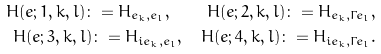<formula> <loc_0><loc_0><loc_500><loc_500>H ( e ; 1 , k , l ) \colon = H _ { e _ { k } , e _ { l } } , \quad H ( e ; 2 , k , l ) \colon = H _ { e _ { k } , \Gamma e _ { l } } , \\ H ( e ; 3 , k , l ) \colon = H _ { i e _ { k } , e _ { l } } , \quad H ( e ; 4 , k , l ) \colon = H _ { i e _ { k } , \Gamma e _ { l } } .</formula> 